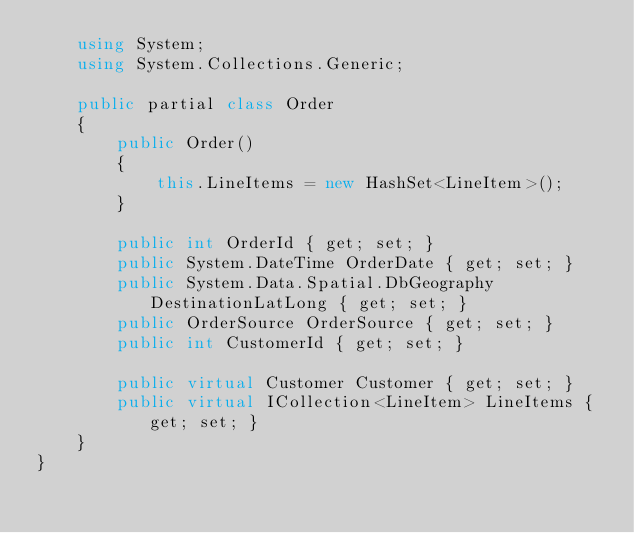Convert code to text. <code><loc_0><loc_0><loc_500><loc_500><_C#_>    using System;
    using System.Collections.Generic;
    
    public partial class Order
    {
        public Order()
        {
            this.LineItems = new HashSet<LineItem>();
        }
    
        public int OrderId { get; set; }
        public System.DateTime OrderDate { get; set; }
        public System.Data.Spatial.DbGeography DestinationLatLong { get; set; }
        public OrderSource OrderSource { get; set; }
        public int CustomerId { get; set; }
    
        public virtual Customer Customer { get; set; }
        public virtual ICollection<LineItem> LineItems { get; set; }
    }
}
</code> 